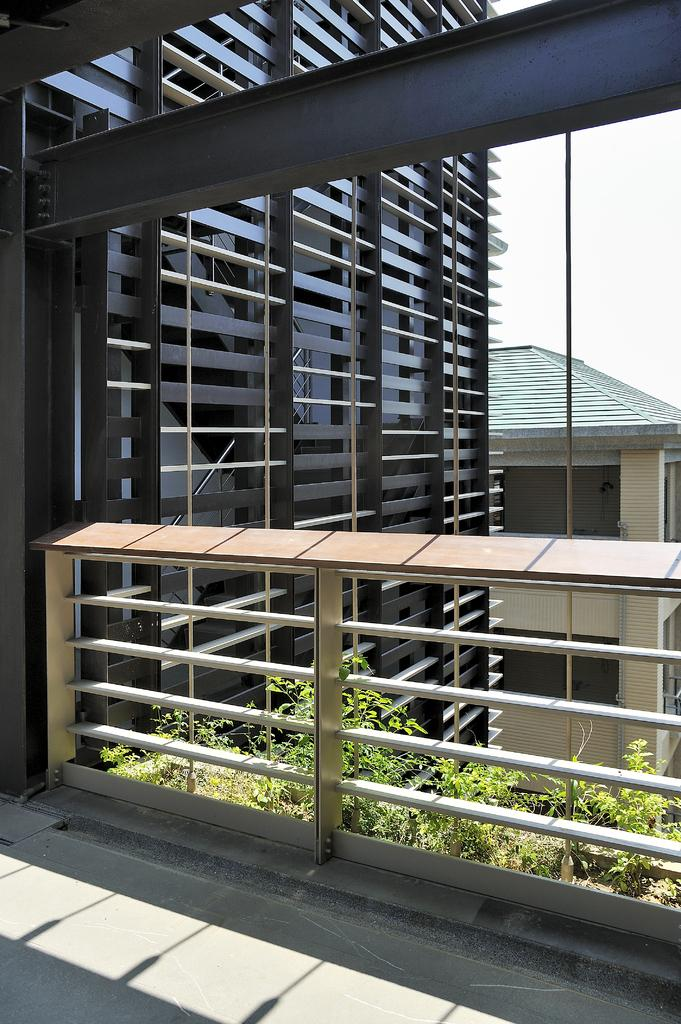What is located in the foreground of the image? There is a fence, plants, and buildings in the foreground of the image. Can you describe the sky in the image? The sky is visible in the top right of the image. When was the image taken? The image was taken during the day. What type of division can be seen in the image? There is no division present in the image; it features a fence, plants, buildings, and the sky. What type of wine or juice is visible in the image? There is no wine or juice present in the image. 